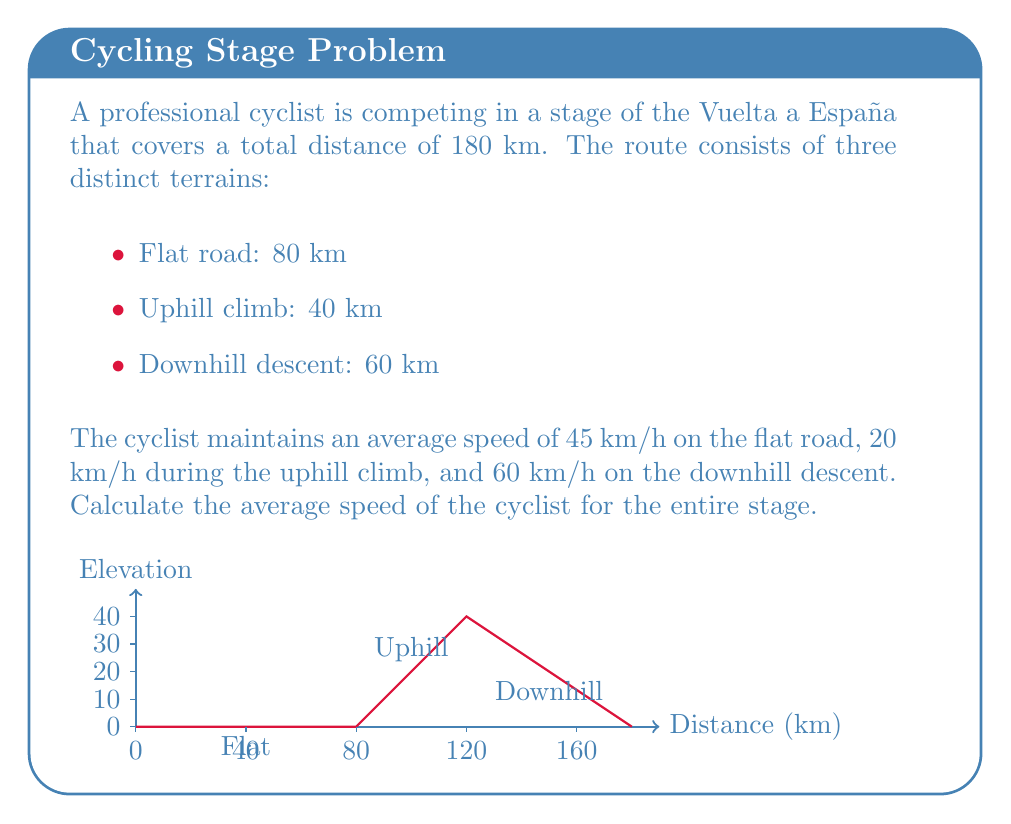Solve this math problem. To solve this problem, we'll use the formula for average speed:

$$ \text{Average Speed} = \frac{\text{Total Distance}}{\text{Total Time}} $$

Let's calculate the time spent on each terrain:

1. Flat road: 
   $t_1 = \frac{80 \text{ km}}{45 \text{ km/h}} = \frac{80}{45} \text{ h} = 1.778 \text{ h}$

2. Uphill climb:
   $t_2 = \frac{40 \text{ km}}{20 \text{ km/h}} = \frac{40}{20} \text{ h} = 2 \text{ h}$

3. Downhill descent:
   $t_3 = \frac{60 \text{ km}}{60 \text{ km/h}} = \frac{60}{60} \text{ h} = 1 \text{ h}$

Total time:
$$ t_{\text{total}} = t_1 + t_2 + t_3 = 1.778 + 2 + 1 = 4.778 \text{ h} $$

Now we can calculate the average speed:

$$ \text{Average Speed} = \frac{180 \text{ km}}{4.778 \text{ h}} = 37.67 \text{ km/h} $$

Rounding to two decimal places, we get 37.67 km/h.
Answer: 37.67 km/h 